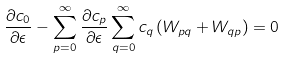<formula> <loc_0><loc_0><loc_500><loc_500>\frac { \partial c _ { 0 } } { \partial \epsilon } - \sum _ { p = 0 } ^ { \infty } \frac { \partial c _ { p } } { \partial \epsilon } \sum _ { q = 0 } ^ { \infty } c _ { q } \left ( W _ { p q } + W _ { q p } \right ) = 0</formula> 